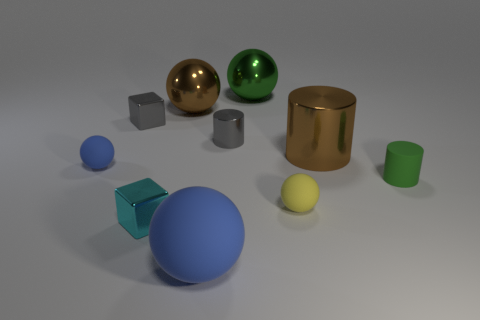What can you infer about the size relationships between the objects? The objects vary in size, which can be inferred by comparing them with one another. The blue and yellow spheres are of different scales, and the cylinders and cubes also differ in their dimensions, suggesting a sense of depth and perspective. 